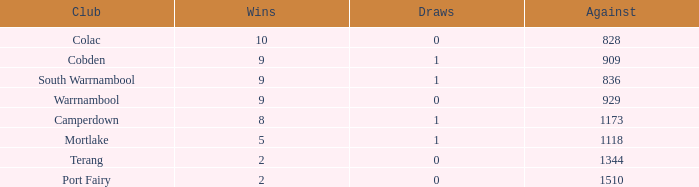For clubs with more than 2 wins, 5 losses, and 0 draws, what is the aggregate of against values? 0.0. 